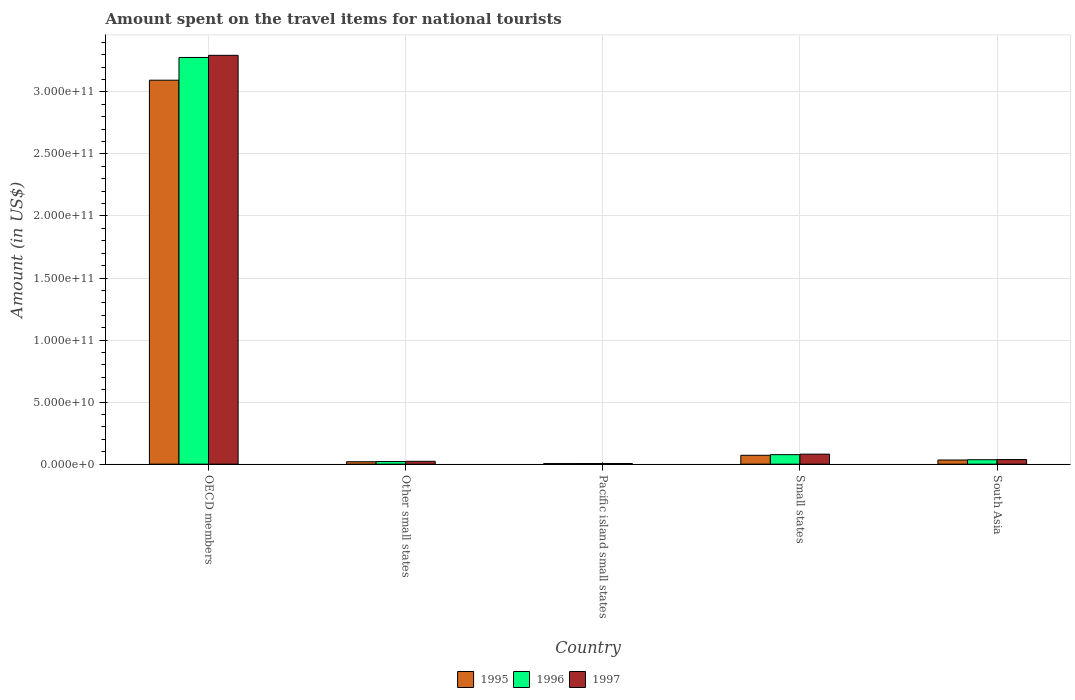Are the number of bars per tick equal to the number of legend labels?
Provide a succinct answer. Yes. What is the label of the 1st group of bars from the left?
Ensure brevity in your answer.  OECD members. What is the amount spent on the travel items for national tourists in 1996 in South Asia?
Your answer should be compact. 3.58e+09. Across all countries, what is the maximum amount spent on the travel items for national tourists in 1996?
Provide a short and direct response. 3.28e+11. Across all countries, what is the minimum amount spent on the travel items for national tourists in 1995?
Provide a short and direct response. 4.74e+08. In which country was the amount spent on the travel items for national tourists in 1996 minimum?
Offer a terse response. Pacific island small states. What is the total amount spent on the travel items for national tourists in 1995 in the graph?
Provide a short and direct response. 3.22e+11. What is the difference between the amount spent on the travel items for national tourists in 1996 in OECD members and that in South Asia?
Your response must be concise. 3.24e+11. What is the difference between the amount spent on the travel items for national tourists in 1995 in OECD members and the amount spent on the travel items for national tourists in 1996 in South Asia?
Provide a succinct answer. 3.06e+11. What is the average amount spent on the travel items for national tourists in 1997 per country?
Offer a very short reply. 6.88e+1. What is the difference between the amount spent on the travel items for national tourists of/in 1996 and amount spent on the travel items for national tourists of/in 1995 in Other small states?
Give a very brief answer. 1.64e+08. In how many countries, is the amount spent on the travel items for national tourists in 1997 greater than 50000000000 US$?
Your answer should be very brief. 1. What is the ratio of the amount spent on the travel items for national tourists in 1995 in Other small states to that in South Asia?
Provide a short and direct response. 0.58. Is the difference between the amount spent on the travel items for national tourists in 1996 in OECD members and Small states greater than the difference between the amount spent on the travel items for national tourists in 1995 in OECD members and Small states?
Make the answer very short. Yes. What is the difference between the highest and the second highest amount spent on the travel items for national tourists in 1997?
Make the answer very short. 3.26e+11. What is the difference between the highest and the lowest amount spent on the travel items for national tourists in 1997?
Keep it short and to the point. 3.29e+11. In how many countries, is the amount spent on the travel items for national tourists in 1996 greater than the average amount spent on the travel items for national tourists in 1996 taken over all countries?
Provide a short and direct response. 1. Is the sum of the amount spent on the travel items for national tourists in 1997 in OECD members and South Asia greater than the maximum amount spent on the travel items for national tourists in 1995 across all countries?
Offer a very short reply. Yes. What does the 2nd bar from the right in Pacific island small states represents?
Provide a short and direct response. 1996. Is it the case that in every country, the sum of the amount spent on the travel items for national tourists in 1996 and amount spent on the travel items for national tourists in 1995 is greater than the amount spent on the travel items for national tourists in 1997?
Your answer should be very brief. Yes. How many bars are there?
Provide a short and direct response. 15. Are all the bars in the graph horizontal?
Your answer should be very brief. No. What is the difference between two consecutive major ticks on the Y-axis?
Your answer should be compact. 5.00e+1. Are the values on the major ticks of Y-axis written in scientific E-notation?
Offer a terse response. Yes. Where does the legend appear in the graph?
Ensure brevity in your answer.  Bottom center. How are the legend labels stacked?
Offer a terse response. Horizontal. What is the title of the graph?
Your answer should be compact. Amount spent on the travel items for national tourists. Does "1965" appear as one of the legend labels in the graph?
Offer a very short reply. No. What is the label or title of the X-axis?
Provide a short and direct response. Country. What is the Amount (in US$) of 1995 in OECD members?
Your response must be concise. 3.09e+11. What is the Amount (in US$) in 1996 in OECD members?
Your response must be concise. 3.28e+11. What is the Amount (in US$) in 1997 in OECD members?
Ensure brevity in your answer.  3.29e+11. What is the Amount (in US$) in 1995 in Other small states?
Your answer should be compact. 1.95e+09. What is the Amount (in US$) in 1996 in Other small states?
Provide a short and direct response. 2.12e+09. What is the Amount (in US$) of 1997 in Other small states?
Ensure brevity in your answer.  2.29e+09. What is the Amount (in US$) in 1995 in Pacific island small states?
Provide a succinct answer. 4.74e+08. What is the Amount (in US$) in 1996 in Pacific island small states?
Ensure brevity in your answer.  5.03e+08. What is the Amount (in US$) in 1997 in Pacific island small states?
Provide a short and direct response. 5.15e+08. What is the Amount (in US$) of 1995 in Small states?
Your answer should be compact. 7.16e+09. What is the Amount (in US$) of 1996 in Small states?
Offer a very short reply. 7.67e+09. What is the Amount (in US$) in 1997 in Small states?
Offer a very short reply. 8.07e+09. What is the Amount (in US$) in 1995 in South Asia?
Your response must be concise. 3.35e+09. What is the Amount (in US$) of 1996 in South Asia?
Make the answer very short. 3.58e+09. What is the Amount (in US$) of 1997 in South Asia?
Give a very brief answer. 3.71e+09. Across all countries, what is the maximum Amount (in US$) in 1995?
Provide a short and direct response. 3.09e+11. Across all countries, what is the maximum Amount (in US$) of 1996?
Give a very brief answer. 3.28e+11. Across all countries, what is the maximum Amount (in US$) of 1997?
Offer a very short reply. 3.29e+11. Across all countries, what is the minimum Amount (in US$) in 1995?
Make the answer very short. 4.74e+08. Across all countries, what is the minimum Amount (in US$) in 1996?
Ensure brevity in your answer.  5.03e+08. Across all countries, what is the minimum Amount (in US$) in 1997?
Provide a short and direct response. 5.15e+08. What is the total Amount (in US$) of 1995 in the graph?
Provide a short and direct response. 3.22e+11. What is the total Amount (in US$) of 1996 in the graph?
Your answer should be very brief. 3.42e+11. What is the total Amount (in US$) in 1997 in the graph?
Make the answer very short. 3.44e+11. What is the difference between the Amount (in US$) in 1995 in OECD members and that in Other small states?
Your answer should be compact. 3.07e+11. What is the difference between the Amount (in US$) of 1996 in OECD members and that in Other small states?
Ensure brevity in your answer.  3.26e+11. What is the difference between the Amount (in US$) in 1997 in OECD members and that in Other small states?
Your response must be concise. 3.27e+11. What is the difference between the Amount (in US$) of 1995 in OECD members and that in Pacific island small states?
Keep it short and to the point. 3.09e+11. What is the difference between the Amount (in US$) in 1996 in OECD members and that in Pacific island small states?
Your response must be concise. 3.27e+11. What is the difference between the Amount (in US$) in 1997 in OECD members and that in Pacific island small states?
Keep it short and to the point. 3.29e+11. What is the difference between the Amount (in US$) in 1995 in OECD members and that in Small states?
Your response must be concise. 3.02e+11. What is the difference between the Amount (in US$) in 1996 in OECD members and that in Small states?
Your response must be concise. 3.20e+11. What is the difference between the Amount (in US$) of 1997 in OECD members and that in Small states?
Keep it short and to the point. 3.21e+11. What is the difference between the Amount (in US$) of 1995 in OECD members and that in South Asia?
Provide a short and direct response. 3.06e+11. What is the difference between the Amount (in US$) of 1996 in OECD members and that in South Asia?
Your answer should be very brief. 3.24e+11. What is the difference between the Amount (in US$) in 1997 in OECD members and that in South Asia?
Give a very brief answer. 3.26e+11. What is the difference between the Amount (in US$) in 1995 in Other small states and that in Pacific island small states?
Keep it short and to the point. 1.48e+09. What is the difference between the Amount (in US$) of 1996 in Other small states and that in Pacific island small states?
Ensure brevity in your answer.  1.62e+09. What is the difference between the Amount (in US$) in 1997 in Other small states and that in Pacific island small states?
Make the answer very short. 1.77e+09. What is the difference between the Amount (in US$) in 1995 in Other small states and that in Small states?
Ensure brevity in your answer.  -5.21e+09. What is the difference between the Amount (in US$) of 1996 in Other small states and that in Small states?
Provide a short and direct response. -5.55e+09. What is the difference between the Amount (in US$) in 1997 in Other small states and that in Small states?
Make the answer very short. -5.78e+09. What is the difference between the Amount (in US$) of 1995 in Other small states and that in South Asia?
Offer a terse response. -1.39e+09. What is the difference between the Amount (in US$) of 1996 in Other small states and that in South Asia?
Your answer should be compact. -1.46e+09. What is the difference between the Amount (in US$) in 1997 in Other small states and that in South Asia?
Keep it short and to the point. -1.43e+09. What is the difference between the Amount (in US$) in 1995 in Pacific island small states and that in Small states?
Make the answer very short. -6.69e+09. What is the difference between the Amount (in US$) of 1996 in Pacific island small states and that in Small states?
Give a very brief answer. -7.16e+09. What is the difference between the Amount (in US$) in 1997 in Pacific island small states and that in Small states?
Keep it short and to the point. -7.56e+09. What is the difference between the Amount (in US$) of 1995 in Pacific island small states and that in South Asia?
Offer a very short reply. -2.87e+09. What is the difference between the Amount (in US$) in 1996 in Pacific island small states and that in South Asia?
Your response must be concise. -3.08e+09. What is the difference between the Amount (in US$) in 1997 in Pacific island small states and that in South Asia?
Offer a terse response. -3.20e+09. What is the difference between the Amount (in US$) in 1995 in Small states and that in South Asia?
Your answer should be very brief. 3.81e+09. What is the difference between the Amount (in US$) of 1996 in Small states and that in South Asia?
Keep it short and to the point. 4.09e+09. What is the difference between the Amount (in US$) in 1997 in Small states and that in South Asia?
Give a very brief answer. 4.36e+09. What is the difference between the Amount (in US$) of 1995 in OECD members and the Amount (in US$) of 1996 in Other small states?
Offer a very short reply. 3.07e+11. What is the difference between the Amount (in US$) in 1995 in OECD members and the Amount (in US$) in 1997 in Other small states?
Your answer should be compact. 3.07e+11. What is the difference between the Amount (in US$) in 1996 in OECD members and the Amount (in US$) in 1997 in Other small states?
Offer a terse response. 3.25e+11. What is the difference between the Amount (in US$) of 1995 in OECD members and the Amount (in US$) of 1996 in Pacific island small states?
Offer a very short reply. 3.09e+11. What is the difference between the Amount (in US$) of 1995 in OECD members and the Amount (in US$) of 1997 in Pacific island small states?
Offer a terse response. 3.09e+11. What is the difference between the Amount (in US$) in 1996 in OECD members and the Amount (in US$) in 1997 in Pacific island small states?
Provide a succinct answer. 3.27e+11. What is the difference between the Amount (in US$) in 1995 in OECD members and the Amount (in US$) in 1996 in Small states?
Provide a succinct answer. 3.02e+11. What is the difference between the Amount (in US$) of 1995 in OECD members and the Amount (in US$) of 1997 in Small states?
Your answer should be compact. 3.01e+11. What is the difference between the Amount (in US$) of 1996 in OECD members and the Amount (in US$) of 1997 in Small states?
Your answer should be compact. 3.20e+11. What is the difference between the Amount (in US$) of 1995 in OECD members and the Amount (in US$) of 1996 in South Asia?
Ensure brevity in your answer.  3.06e+11. What is the difference between the Amount (in US$) of 1995 in OECD members and the Amount (in US$) of 1997 in South Asia?
Keep it short and to the point. 3.06e+11. What is the difference between the Amount (in US$) of 1996 in OECD members and the Amount (in US$) of 1997 in South Asia?
Keep it short and to the point. 3.24e+11. What is the difference between the Amount (in US$) in 1995 in Other small states and the Amount (in US$) in 1996 in Pacific island small states?
Provide a succinct answer. 1.45e+09. What is the difference between the Amount (in US$) of 1995 in Other small states and the Amount (in US$) of 1997 in Pacific island small states?
Your response must be concise. 1.44e+09. What is the difference between the Amount (in US$) in 1996 in Other small states and the Amount (in US$) in 1997 in Pacific island small states?
Offer a terse response. 1.60e+09. What is the difference between the Amount (in US$) of 1995 in Other small states and the Amount (in US$) of 1996 in Small states?
Give a very brief answer. -5.71e+09. What is the difference between the Amount (in US$) in 1995 in Other small states and the Amount (in US$) in 1997 in Small states?
Your answer should be compact. -6.12e+09. What is the difference between the Amount (in US$) of 1996 in Other small states and the Amount (in US$) of 1997 in Small states?
Give a very brief answer. -5.95e+09. What is the difference between the Amount (in US$) of 1995 in Other small states and the Amount (in US$) of 1996 in South Asia?
Offer a terse response. -1.63e+09. What is the difference between the Amount (in US$) in 1995 in Other small states and the Amount (in US$) in 1997 in South Asia?
Your answer should be compact. -1.76e+09. What is the difference between the Amount (in US$) of 1996 in Other small states and the Amount (in US$) of 1997 in South Asia?
Ensure brevity in your answer.  -1.60e+09. What is the difference between the Amount (in US$) in 1995 in Pacific island small states and the Amount (in US$) in 1996 in Small states?
Provide a short and direct response. -7.19e+09. What is the difference between the Amount (in US$) of 1995 in Pacific island small states and the Amount (in US$) of 1997 in Small states?
Provide a short and direct response. -7.60e+09. What is the difference between the Amount (in US$) in 1996 in Pacific island small states and the Amount (in US$) in 1997 in Small states?
Provide a short and direct response. -7.57e+09. What is the difference between the Amount (in US$) in 1995 in Pacific island small states and the Amount (in US$) in 1996 in South Asia?
Give a very brief answer. -3.11e+09. What is the difference between the Amount (in US$) in 1995 in Pacific island small states and the Amount (in US$) in 1997 in South Asia?
Your response must be concise. -3.24e+09. What is the difference between the Amount (in US$) of 1996 in Pacific island small states and the Amount (in US$) of 1997 in South Asia?
Make the answer very short. -3.21e+09. What is the difference between the Amount (in US$) of 1995 in Small states and the Amount (in US$) of 1996 in South Asia?
Your answer should be very brief. 3.58e+09. What is the difference between the Amount (in US$) in 1995 in Small states and the Amount (in US$) in 1997 in South Asia?
Provide a succinct answer. 3.45e+09. What is the difference between the Amount (in US$) of 1996 in Small states and the Amount (in US$) of 1997 in South Asia?
Keep it short and to the point. 3.95e+09. What is the average Amount (in US$) in 1995 per country?
Ensure brevity in your answer.  6.45e+1. What is the average Amount (in US$) of 1996 per country?
Offer a terse response. 6.83e+1. What is the average Amount (in US$) of 1997 per country?
Offer a very short reply. 6.88e+1. What is the difference between the Amount (in US$) of 1995 and Amount (in US$) of 1996 in OECD members?
Give a very brief answer. -1.83e+1. What is the difference between the Amount (in US$) in 1995 and Amount (in US$) in 1997 in OECD members?
Offer a very short reply. -2.01e+1. What is the difference between the Amount (in US$) in 1996 and Amount (in US$) in 1997 in OECD members?
Ensure brevity in your answer.  -1.72e+09. What is the difference between the Amount (in US$) of 1995 and Amount (in US$) of 1996 in Other small states?
Your answer should be very brief. -1.64e+08. What is the difference between the Amount (in US$) in 1995 and Amount (in US$) in 1997 in Other small states?
Offer a terse response. -3.34e+08. What is the difference between the Amount (in US$) in 1996 and Amount (in US$) in 1997 in Other small states?
Your answer should be compact. -1.69e+08. What is the difference between the Amount (in US$) in 1995 and Amount (in US$) in 1996 in Pacific island small states?
Provide a short and direct response. -2.89e+07. What is the difference between the Amount (in US$) in 1995 and Amount (in US$) in 1997 in Pacific island small states?
Your response must be concise. -4.11e+07. What is the difference between the Amount (in US$) in 1996 and Amount (in US$) in 1997 in Pacific island small states?
Give a very brief answer. -1.22e+07. What is the difference between the Amount (in US$) in 1995 and Amount (in US$) in 1996 in Small states?
Your answer should be very brief. -5.07e+08. What is the difference between the Amount (in US$) of 1995 and Amount (in US$) of 1997 in Small states?
Your answer should be compact. -9.12e+08. What is the difference between the Amount (in US$) in 1996 and Amount (in US$) in 1997 in Small states?
Give a very brief answer. -4.05e+08. What is the difference between the Amount (in US$) in 1995 and Amount (in US$) in 1996 in South Asia?
Your answer should be compact. -2.32e+08. What is the difference between the Amount (in US$) in 1995 and Amount (in US$) in 1997 in South Asia?
Keep it short and to the point. -3.67e+08. What is the difference between the Amount (in US$) of 1996 and Amount (in US$) of 1997 in South Asia?
Make the answer very short. -1.35e+08. What is the ratio of the Amount (in US$) in 1995 in OECD members to that in Other small states?
Offer a very short reply. 158.36. What is the ratio of the Amount (in US$) of 1996 in OECD members to that in Other small states?
Offer a very short reply. 154.72. What is the ratio of the Amount (in US$) in 1997 in OECD members to that in Other small states?
Give a very brief answer. 144.02. What is the ratio of the Amount (in US$) in 1995 in OECD members to that in Pacific island small states?
Provide a succinct answer. 652.87. What is the ratio of the Amount (in US$) in 1996 in OECD members to that in Pacific island small states?
Offer a terse response. 651.78. What is the ratio of the Amount (in US$) of 1997 in OECD members to that in Pacific island small states?
Your answer should be compact. 639.7. What is the ratio of the Amount (in US$) in 1995 in OECD members to that in Small states?
Your answer should be compact. 43.22. What is the ratio of the Amount (in US$) of 1996 in OECD members to that in Small states?
Ensure brevity in your answer.  42.76. What is the ratio of the Amount (in US$) in 1997 in OECD members to that in Small states?
Ensure brevity in your answer.  40.82. What is the ratio of the Amount (in US$) in 1995 in OECD members to that in South Asia?
Offer a very short reply. 92.44. What is the ratio of the Amount (in US$) in 1996 in OECD members to that in South Asia?
Offer a terse response. 91.57. What is the ratio of the Amount (in US$) in 1997 in OECD members to that in South Asia?
Offer a very short reply. 88.71. What is the ratio of the Amount (in US$) in 1995 in Other small states to that in Pacific island small states?
Your answer should be compact. 4.12. What is the ratio of the Amount (in US$) of 1996 in Other small states to that in Pacific island small states?
Your response must be concise. 4.21. What is the ratio of the Amount (in US$) of 1997 in Other small states to that in Pacific island small states?
Offer a terse response. 4.44. What is the ratio of the Amount (in US$) of 1995 in Other small states to that in Small states?
Keep it short and to the point. 0.27. What is the ratio of the Amount (in US$) of 1996 in Other small states to that in Small states?
Provide a succinct answer. 0.28. What is the ratio of the Amount (in US$) of 1997 in Other small states to that in Small states?
Provide a short and direct response. 0.28. What is the ratio of the Amount (in US$) in 1995 in Other small states to that in South Asia?
Your answer should be very brief. 0.58. What is the ratio of the Amount (in US$) in 1996 in Other small states to that in South Asia?
Provide a succinct answer. 0.59. What is the ratio of the Amount (in US$) in 1997 in Other small states to that in South Asia?
Provide a short and direct response. 0.62. What is the ratio of the Amount (in US$) of 1995 in Pacific island small states to that in Small states?
Your response must be concise. 0.07. What is the ratio of the Amount (in US$) in 1996 in Pacific island small states to that in Small states?
Your response must be concise. 0.07. What is the ratio of the Amount (in US$) in 1997 in Pacific island small states to that in Small states?
Provide a short and direct response. 0.06. What is the ratio of the Amount (in US$) of 1995 in Pacific island small states to that in South Asia?
Make the answer very short. 0.14. What is the ratio of the Amount (in US$) of 1996 in Pacific island small states to that in South Asia?
Offer a very short reply. 0.14. What is the ratio of the Amount (in US$) of 1997 in Pacific island small states to that in South Asia?
Make the answer very short. 0.14. What is the ratio of the Amount (in US$) in 1995 in Small states to that in South Asia?
Give a very brief answer. 2.14. What is the ratio of the Amount (in US$) of 1996 in Small states to that in South Asia?
Your answer should be very brief. 2.14. What is the ratio of the Amount (in US$) of 1997 in Small states to that in South Asia?
Your answer should be compact. 2.17. What is the difference between the highest and the second highest Amount (in US$) of 1995?
Give a very brief answer. 3.02e+11. What is the difference between the highest and the second highest Amount (in US$) in 1996?
Ensure brevity in your answer.  3.20e+11. What is the difference between the highest and the second highest Amount (in US$) of 1997?
Provide a short and direct response. 3.21e+11. What is the difference between the highest and the lowest Amount (in US$) in 1995?
Make the answer very short. 3.09e+11. What is the difference between the highest and the lowest Amount (in US$) of 1996?
Offer a very short reply. 3.27e+11. What is the difference between the highest and the lowest Amount (in US$) in 1997?
Provide a succinct answer. 3.29e+11. 